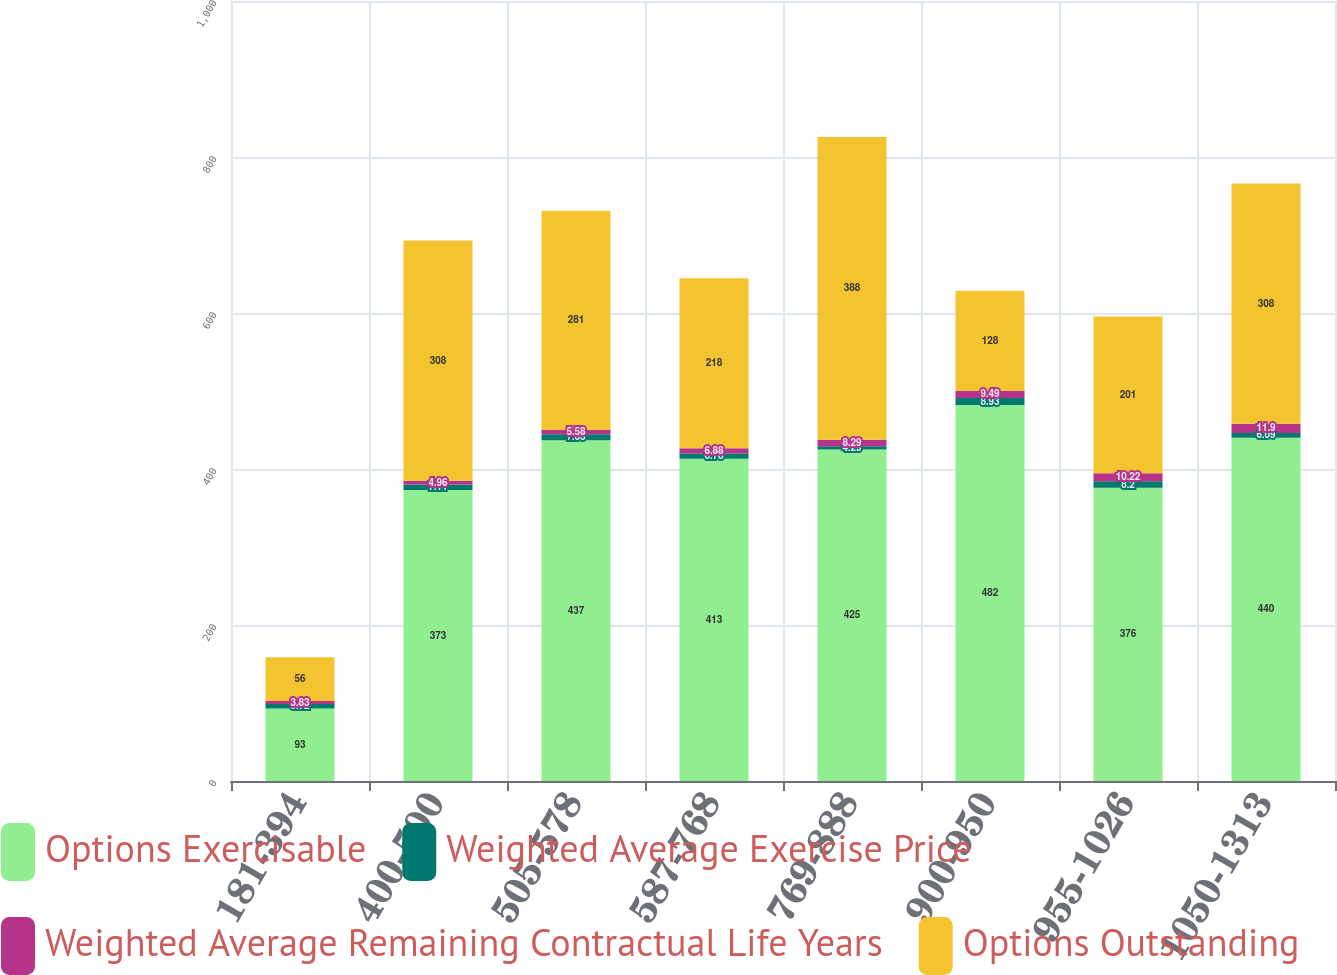Convert chart. <chart><loc_0><loc_0><loc_500><loc_500><stacked_bar_chart><ecel><fcel>181-394<fcel>400-500<fcel>505-578<fcel>587-768<fcel>769-888<fcel>900-950<fcel>955-1026<fcel>1050-1313<nl><fcel>Options Exercisable<fcel>93<fcel>373<fcel>437<fcel>413<fcel>425<fcel>482<fcel>376<fcel>440<nl><fcel>Weighted Average Exercise Price<fcel>5.72<fcel>7.11<fcel>7.63<fcel>6.78<fcel>4.29<fcel>8.93<fcel>8.2<fcel>6.09<nl><fcel>Weighted Average Remaining Contractual Life Years<fcel>3.83<fcel>4.96<fcel>5.58<fcel>6.88<fcel>8.29<fcel>9.49<fcel>10.22<fcel>11.9<nl><fcel>Options Outstanding<fcel>56<fcel>308<fcel>281<fcel>218<fcel>388<fcel>128<fcel>201<fcel>308<nl></chart> 